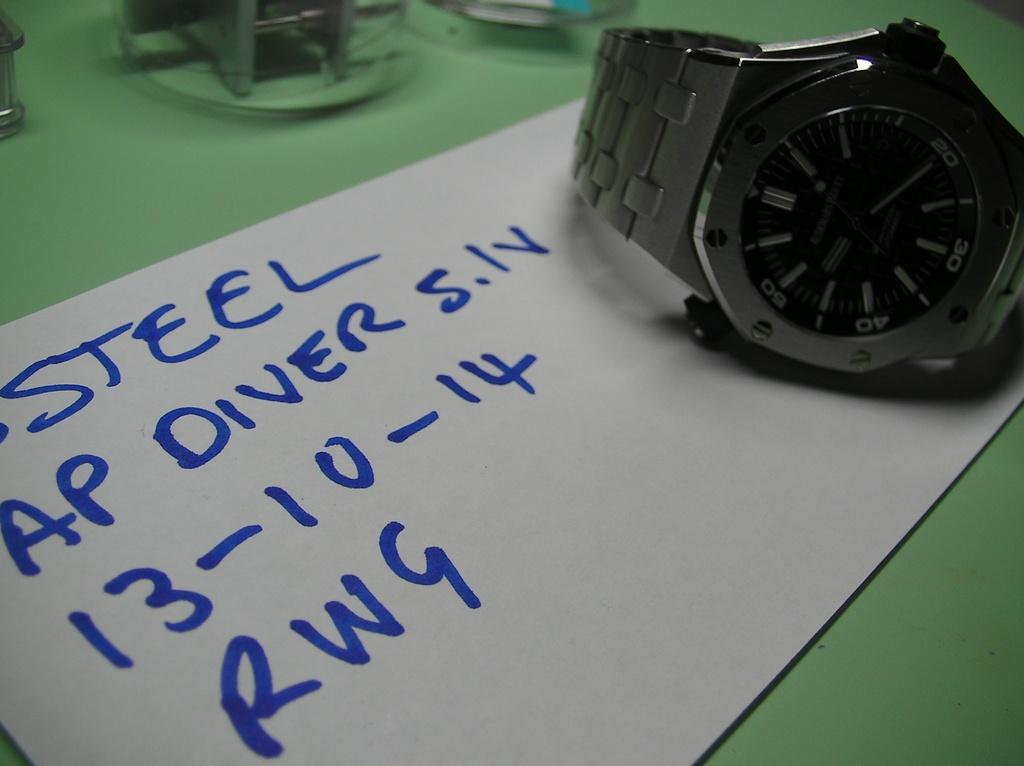<image>
Write a terse but informative summary of the picture. Watch on top of a paper that says STEEL on it. 